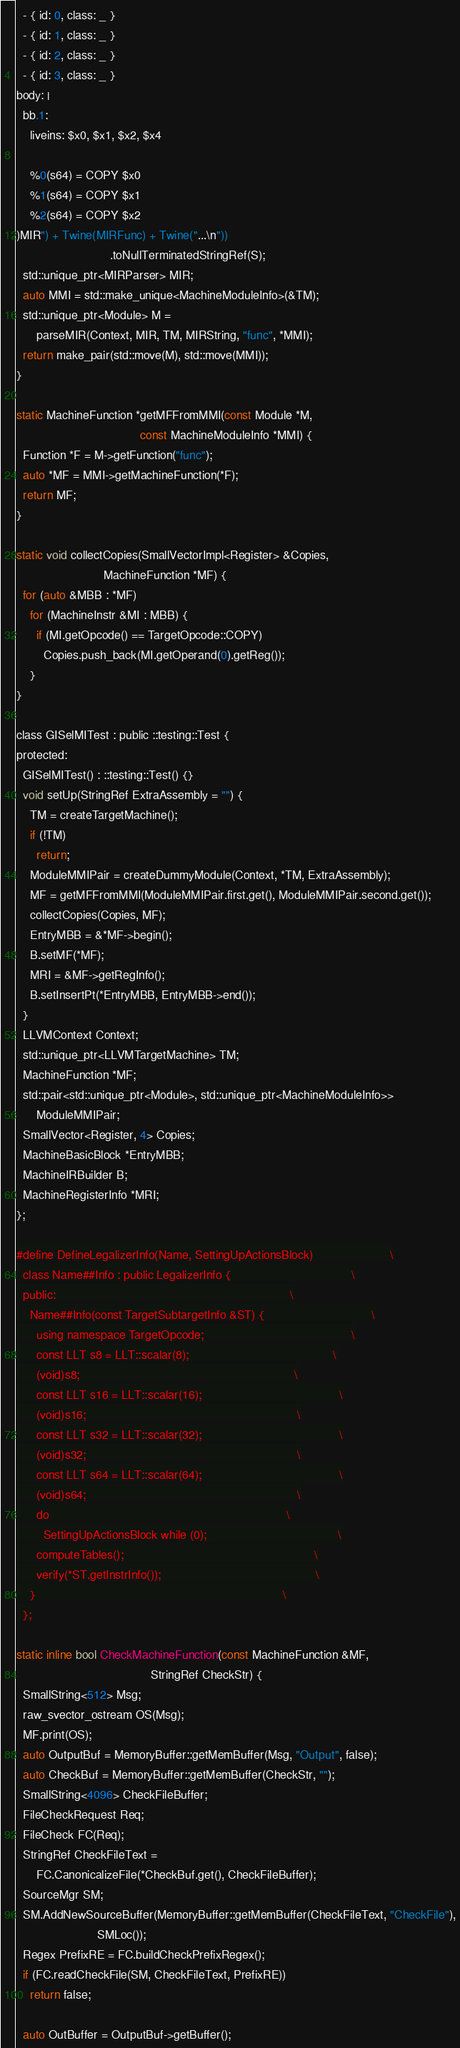Convert code to text. <code><loc_0><loc_0><loc_500><loc_500><_C_>  - { id: 0, class: _ }
  - { id: 1, class: _ }
  - { id: 2, class: _ }
  - { id: 3, class: _ }
body: |
  bb.1:
    liveins: $x0, $x1, $x2, $x4

    %0(s64) = COPY $x0
    %1(s64) = COPY $x1
    %2(s64) = COPY $x2
)MIR") + Twine(MIRFunc) + Twine("...\n"))
                            .toNullTerminatedStringRef(S);
  std::unique_ptr<MIRParser> MIR;
  auto MMI = std::make_unique<MachineModuleInfo>(&TM);
  std::unique_ptr<Module> M =
      parseMIR(Context, MIR, TM, MIRString, "func", *MMI);
  return make_pair(std::move(M), std::move(MMI));
}

static MachineFunction *getMFFromMMI(const Module *M,
                                     const MachineModuleInfo *MMI) {
  Function *F = M->getFunction("func");
  auto *MF = MMI->getMachineFunction(*F);
  return MF;
}

static void collectCopies(SmallVectorImpl<Register> &Copies,
                          MachineFunction *MF) {
  for (auto &MBB : *MF)
    for (MachineInstr &MI : MBB) {
      if (MI.getOpcode() == TargetOpcode::COPY)
        Copies.push_back(MI.getOperand(0).getReg());
    }
}

class GISelMITest : public ::testing::Test {
protected:
  GISelMITest() : ::testing::Test() {}
  void setUp(StringRef ExtraAssembly = "") {
    TM = createTargetMachine();
    if (!TM)
      return;
    ModuleMMIPair = createDummyModule(Context, *TM, ExtraAssembly);
    MF = getMFFromMMI(ModuleMMIPair.first.get(), ModuleMMIPair.second.get());
    collectCopies(Copies, MF);
    EntryMBB = &*MF->begin();
    B.setMF(*MF);
    MRI = &MF->getRegInfo();
    B.setInsertPt(*EntryMBB, EntryMBB->end());
  }
  LLVMContext Context;
  std::unique_ptr<LLVMTargetMachine> TM;
  MachineFunction *MF;
  std::pair<std::unique_ptr<Module>, std::unique_ptr<MachineModuleInfo>>
      ModuleMMIPair;
  SmallVector<Register, 4> Copies;
  MachineBasicBlock *EntryMBB;
  MachineIRBuilder B;
  MachineRegisterInfo *MRI;
};

#define DefineLegalizerInfo(Name, SettingUpActionsBlock)                       \
  class Name##Info : public LegalizerInfo {                                    \
  public:                                                                      \
    Name##Info(const TargetSubtargetInfo &ST) {                                \
      using namespace TargetOpcode;                                            \
      const LLT s8 = LLT::scalar(8);                                           \
      (void)s8;                                                                \
      const LLT s16 = LLT::scalar(16);                                         \
      (void)s16;                                                               \
      const LLT s32 = LLT::scalar(32);                                         \
      (void)s32;                                                               \
      const LLT s64 = LLT::scalar(64);                                         \
      (void)s64;                                                               \
      do                                                                       \
        SettingUpActionsBlock while (0);                                       \
      computeTables();                                                         \
      verify(*ST.getInstrInfo());                                              \
    }                                                                          \
  };

static inline bool CheckMachineFunction(const MachineFunction &MF,
                                        StringRef CheckStr) {
  SmallString<512> Msg;
  raw_svector_ostream OS(Msg);
  MF.print(OS);
  auto OutputBuf = MemoryBuffer::getMemBuffer(Msg, "Output", false);
  auto CheckBuf = MemoryBuffer::getMemBuffer(CheckStr, "");
  SmallString<4096> CheckFileBuffer;
  FileCheckRequest Req;
  FileCheck FC(Req);
  StringRef CheckFileText =
      FC.CanonicalizeFile(*CheckBuf.get(), CheckFileBuffer);
  SourceMgr SM;
  SM.AddNewSourceBuffer(MemoryBuffer::getMemBuffer(CheckFileText, "CheckFile"),
                        SMLoc());
  Regex PrefixRE = FC.buildCheckPrefixRegex();
  if (FC.readCheckFile(SM, CheckFileText, PrefixRE))
    return false;

  auto OutBuffer = OutputBuf->getBuffer();</code> 